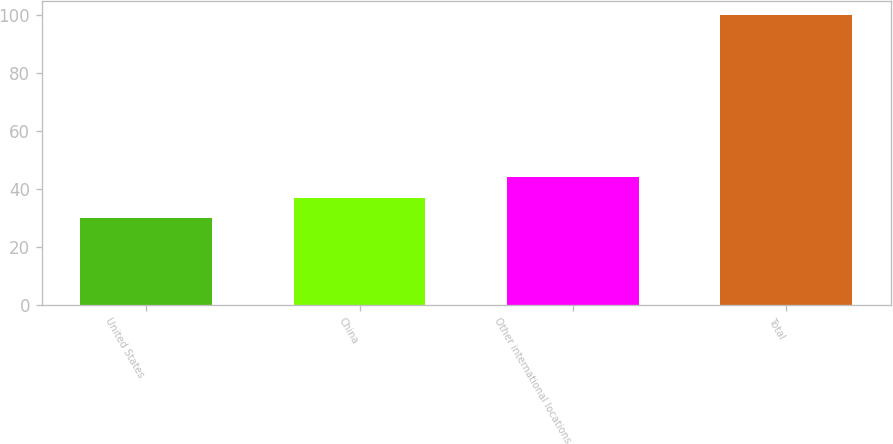Convert chart. <chart><loc_0><loc_0><loc_500><loc_500><bar_chart><fcel>United States<fcel>China<fcel>Other international locations<fcel>Total<nl><fcel>30<fcel>37<fcel>44<fcel>100<nl></chart> 